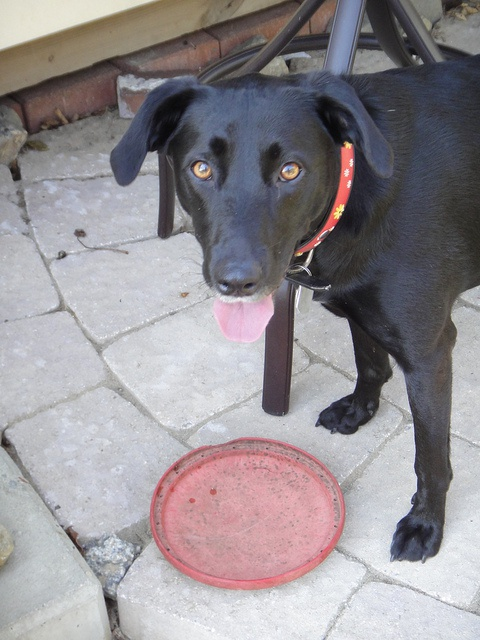Describe the objects in this image and their specific colors. I can see dog in lightgray, gray, and black tones and frisbee in lightgray, lightpink, darkgray, and salmon tones in this image. 